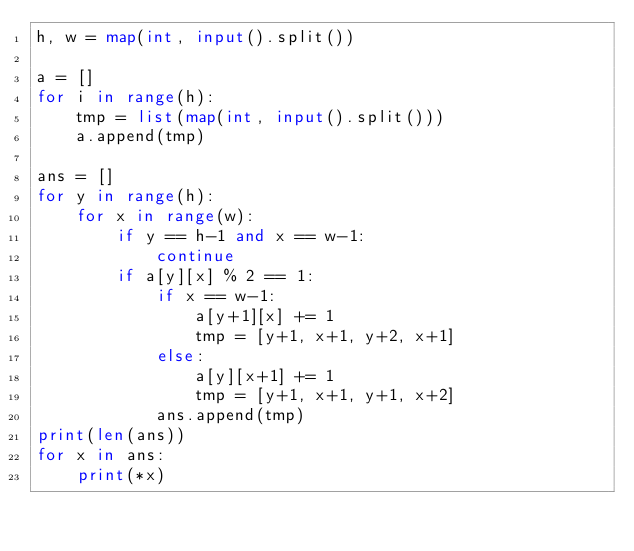Convert code to text. <code><loc_0><loc_0><loc_500><loc_500><_Python_>h, w = map(int, input().split())

a = []
for i in range(h):
    tmp = list(map(int, input().split()))
    a.append(tmp)

ans = []
for y in range(h):
    for x in range(w):
        if y == h-1 and x == w-1:
            continue
        if a[y][x] % 2 == 1:
            if x == w-1:
                a[y+1][x] += 1
                tmp = [y+1, x+1, y+2, x+1]
            else:
                a[y][x+1] += 1
                tmp = [y+1, x+1, y+1, x+2]
            ans.append(tmp)
print(len(ans))
for x in ans:
    print(*x)</code> 